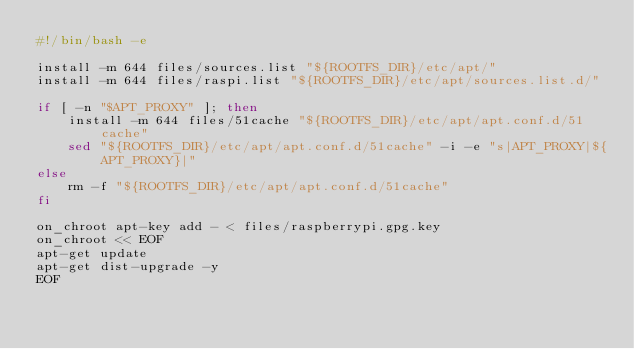<code> <loc_0><loc_0><loc_500><loc_500><_Bash_>#!/bin/bash -e

install -m 644 files/sources.list "${ROOTFS_DIR}/etc/apt/"
install -m 644 files/raspi.list "${ROOTFS_DIR}/etc/apt/sources.list.d/"

if [ -n "$APT_PROXY" ]; then
	install -m 644 files/51cache "${ROOTFS_DIR}/etc/apt/apt.conf.d/51cache"
	sed "${ROOTFS_DIR}/etc/apt/apt.conf.d/51cache" -i -e "s|APT_PROXY|${APT_PROXY}|"
else
	rm -f "${ROOTFS_DIR}/etc/apt/apt.conf.d/51cache"
fi

on_chroot apt-key add - < files/raspberrypi.gpg.key
on_chroot << EOF
apt-get update
apt-get dist-upgrade -y
EOF
</code> 